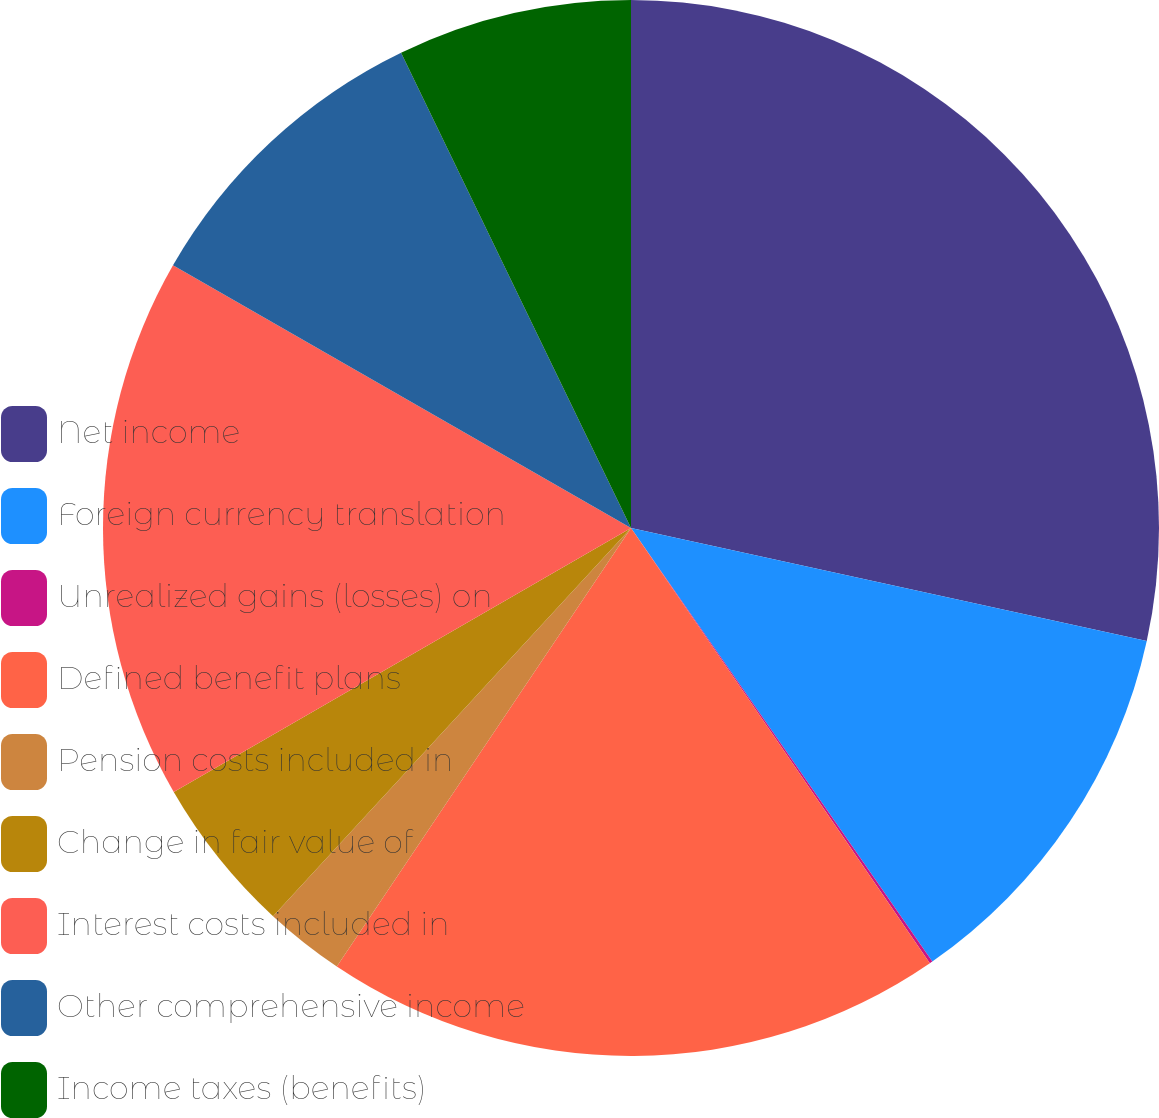<chart> <loc_0><loc_0><loc_500><loc_500><pie_chart><fcel>Net income<fcel>Foreign currency translation<fcel>Unrealized gains (losses) on<fcel>Defined benefit plans<fcel>Pension costs included in<fcel>Change in fair value of<fcel>Interest costs included in<fcel>Other comprehensive income<fcel>Income taxes (benefits)<nl><fcel>28.43%<fcel>11.9%<fcel>0.09%<fcel>18.98%<fcel>2.45%<fcel>4.81%<fcel>16.62%<fcel>9.54%<fcel>7.17%<nl></chart> 